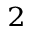<formula> <loc_0><loc_0><loc_500><loc_500>^ { 2 }</formula> 